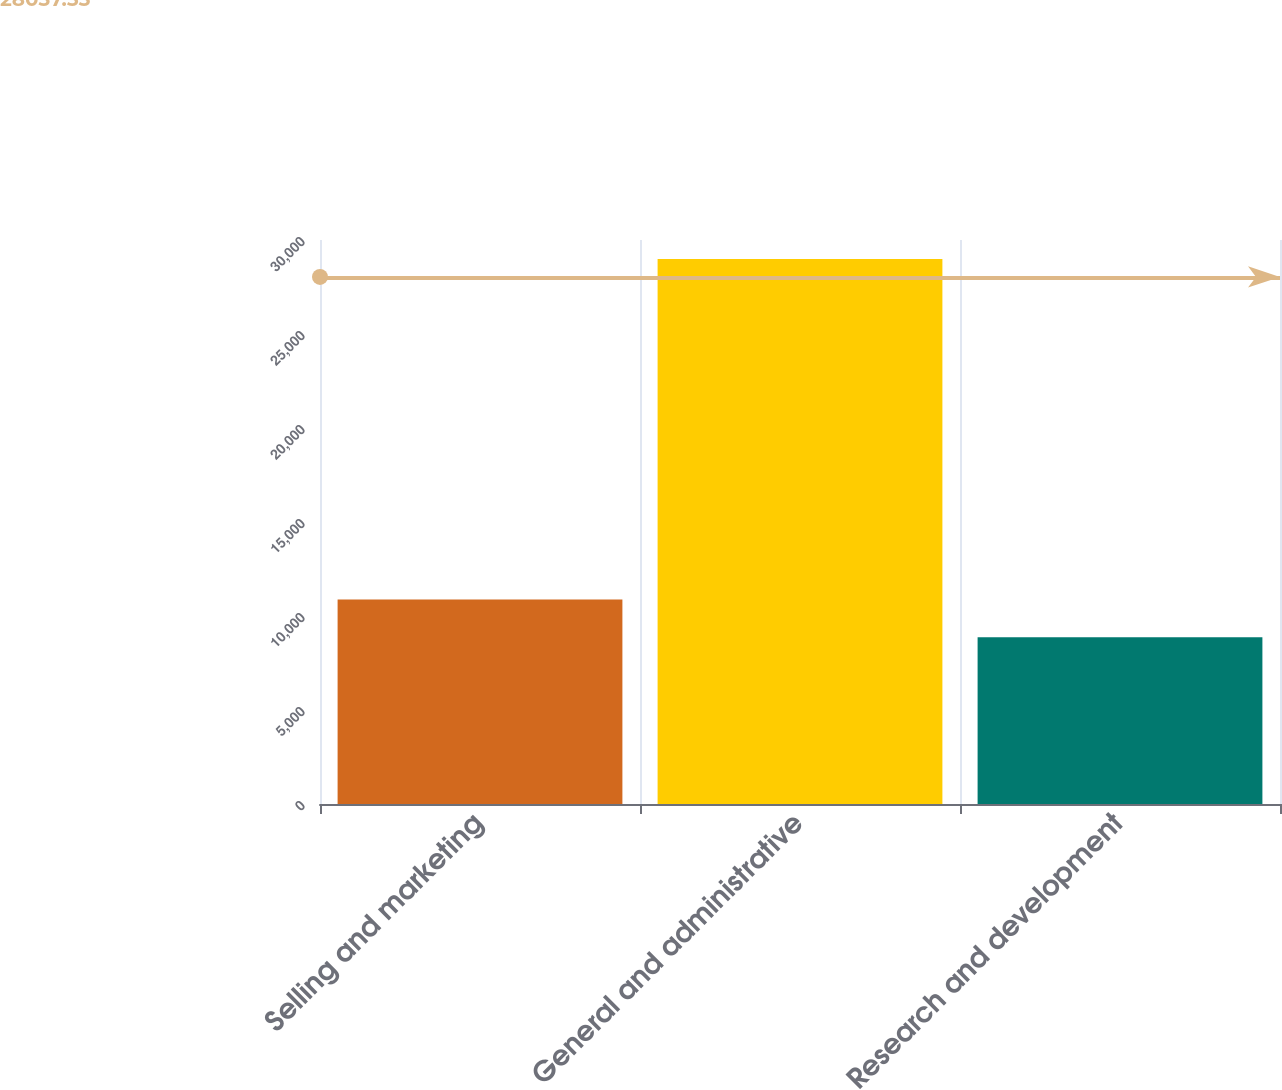<chart> <loc_0><loc_0><loc_500><loc_500><bar_chart><fcel>Selling and marketing<fcel>General and administrative<fcel>Research and development<nl><fcel>10879.4<fcel>28991<fcel>8867<nl></chart> 